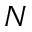Convert formula to latex. <formula><loc_0><loc_0><loc_500><loc_500>N</formula> 